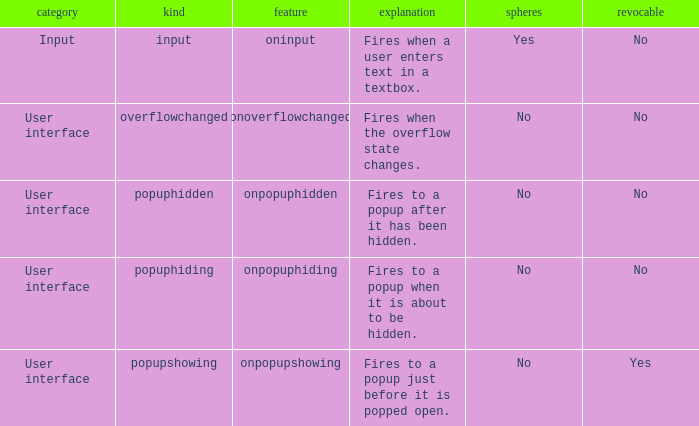What's the cancelable with bubbles being yes No. 